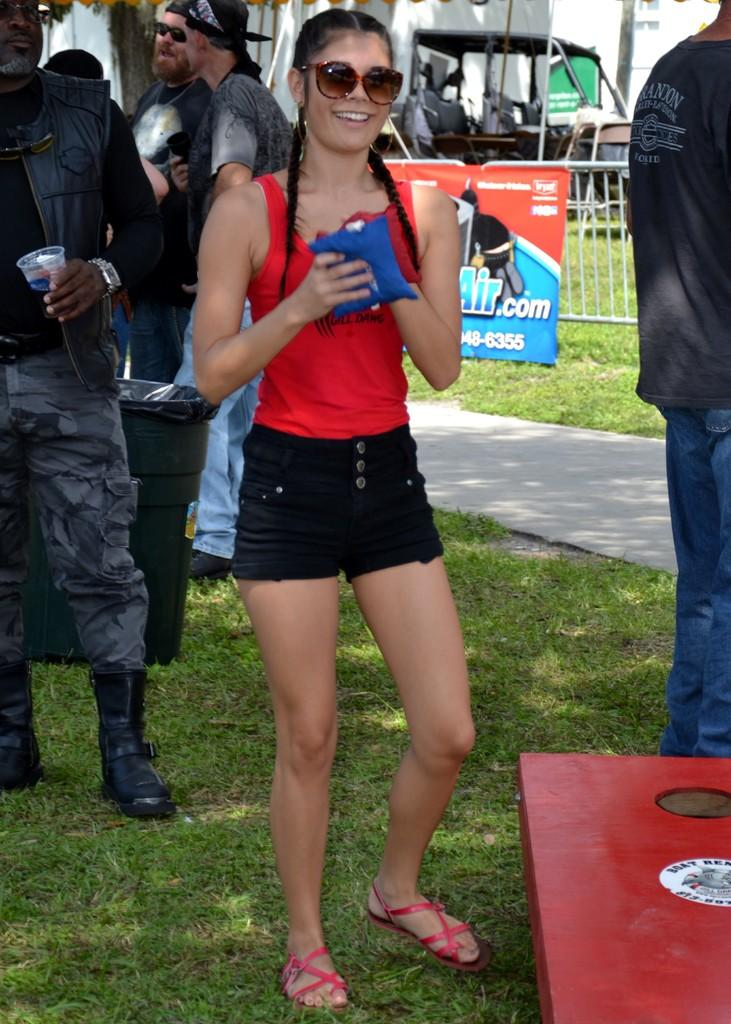What is the woman in the image doing? The woman is standing on the grass and smiling in the image. How many people are in the image? There are people in the image, but the exact number is not specified. What can be seen in the image besides the people? There is a bin, a path, a fence, and a banner in the image, as well as other objects. What type of power source is being used to move the woman in the image? There is no indication in the image that the woman is being moved by any power source; she is standing on the grass. 